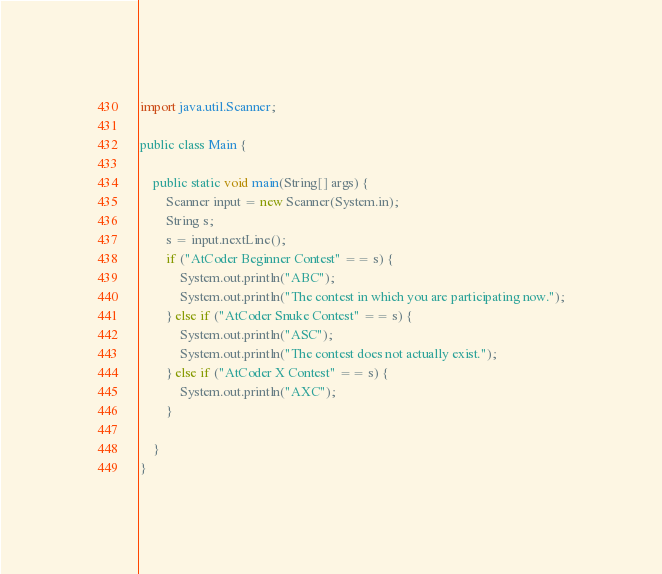<code> <loc_0><loc_0><loc_500><loc_500><_Java_>
import java.util.Scanner;

public class Main {

    public static void main(String[] args) {
        Scanner input = new Scanner(System.in);
        String s;
        s = input.nextLine();
        if ("AtCoder Beginner Contest" == s) {
            System.out.println("ABC");
            System.out.println("The contest in which you are participating now.");
        } else if ("AtCoder Snuke Contest" == s) {
            System.out.println("ASC");
            System.out.println("The contest does not actually exist.");
        } else if ("AtCoder X Contest" == s) {
            System.out.println("AXC");
        }

    }
}</code> 